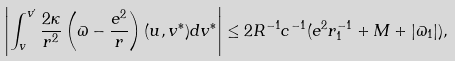<formula> <loc_0><loc_0><loc_500><loc_500>\left | \int _ { v } ^ { v ^ { \prime } } { \frac { 2 \kappa } { r ^ { 2 } } \left ( \varpi - \frac { e ^ { 2 } } r \right ) ( u , v ^ { * } ) d v ^ { * } } \right | \leq 2 R ^ { - 1 } c ^ { - 1 } ( e ^ { 2 } r _ { 1 } ^ { - 1 } + M + | \varpi _ { 1 } | ) ,</formula> 